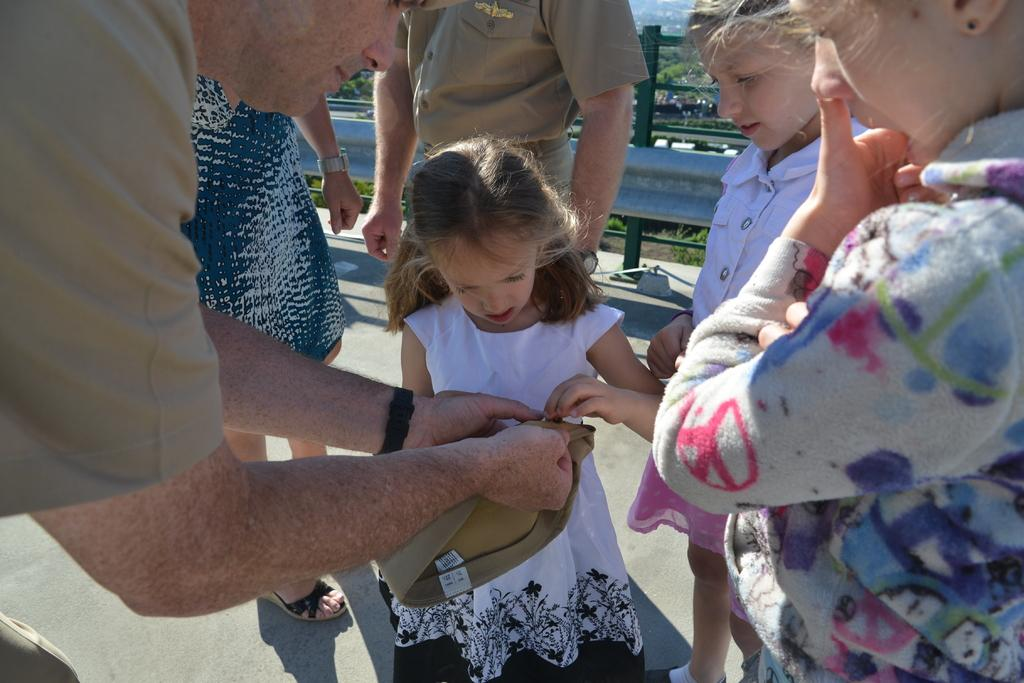How many people are in the image? There are people in the image, but the exact number is not specified. What is one person holding in the image? One person is holding a cap in the image. What type of barrier can be seen in the image? There is fencing in the image. What type of vegetation is present in the image? Plants and trees are visible in the image. Reasoning: Let'g: Let's think step by step in order to produce the conversation. We start by acknowledging the presence of people in the image, but we avoid specifying an exact number since it is not mentioned in the facts. Next, we identify a specific item that one person is holding, which is the cap. Then, we mention the fencing as a type of barrier present in the image. Finally, we describe the vegetation present in the image, which includes both plants and trees. Absurd Question/Answer: Can you see a snail crawling on the fencing in the image? No, there is no snail visible on the fencing in the image. 